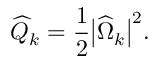Convert formula to latex. <formula><loc_0><loc_0><loc_500><loc_500>\widehat { Q } _ { k } = \frac { 1 } { 2 } \left | \widehat { \Omega } _ { k } \right | ^ { 2 } .</formula> 